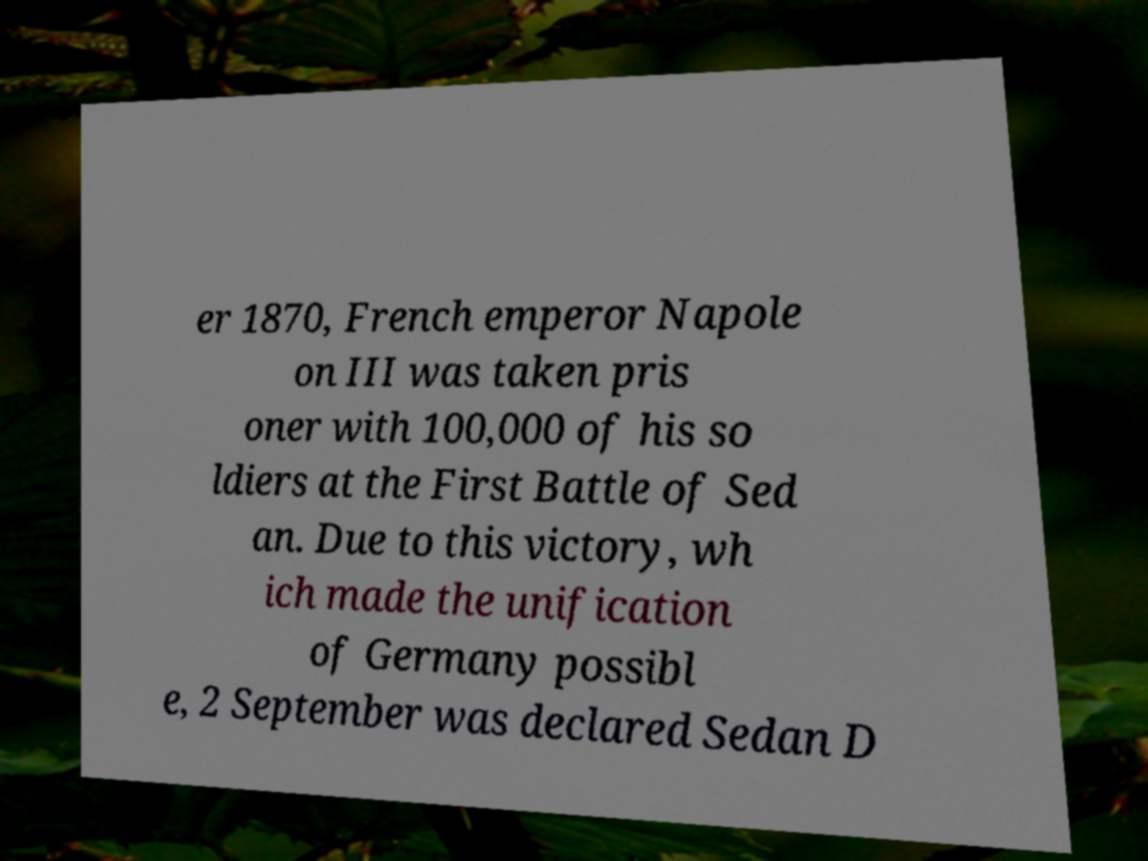Please identify and transcribe the text found in this image. er 1870, French emperor Napole on III was taken pris oner with 100,000 of his so ldiers at the First Battle of Sed an. Due to this victory, wh ich made the unification of Germany possibl e, 2 September was declared Sedan D 